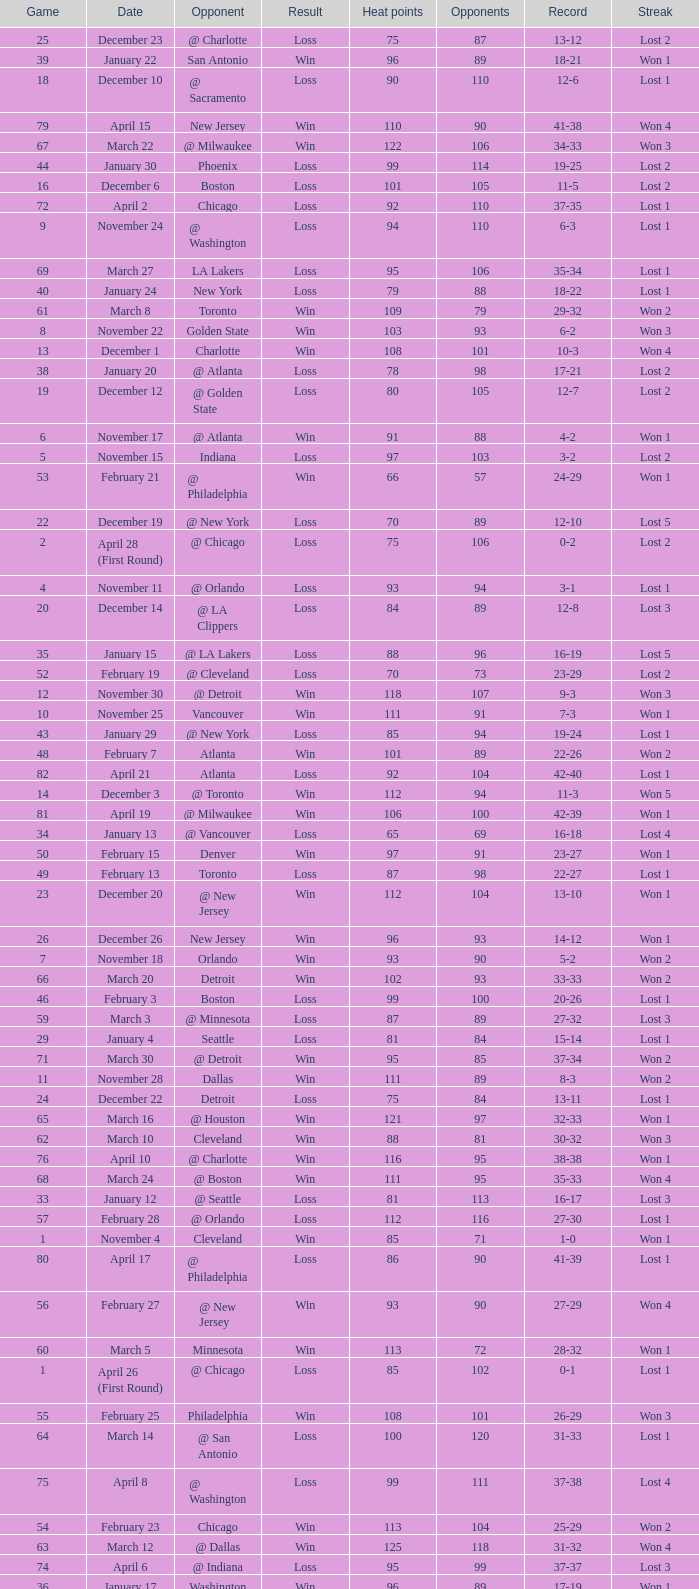What is Streak, when Heat Points is "101", and when Game is "16"? Lost 2. 